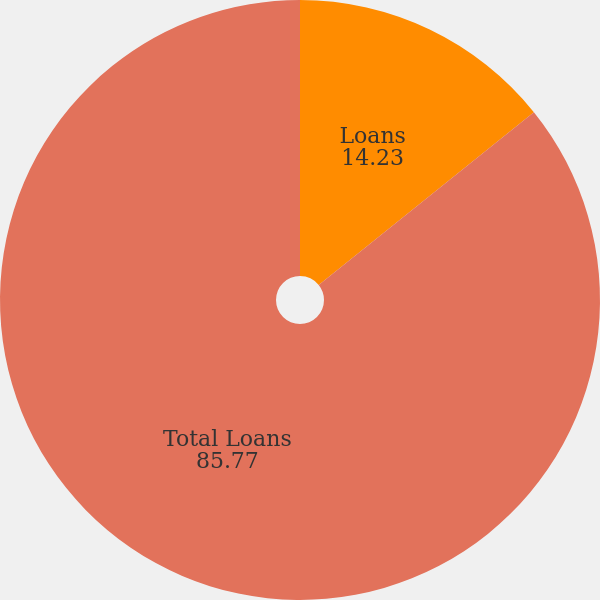<chart> <loc_0><loc_0><loc_500><loc_500><pie_chart><fcel>Loans<fcel>Total Loans<nl><fcel>14.23%<fcel>85.77%<nl></chart> 